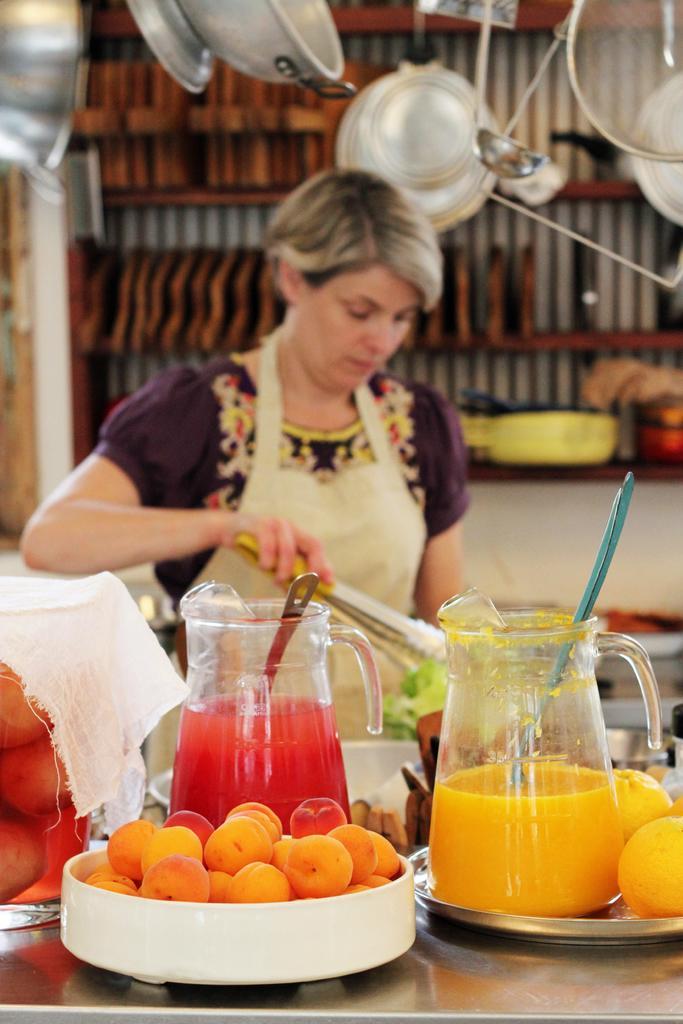Please provide a concise description of this image. In the middle of the picture, we see a woman is standing. She is holding something in her hands. In front of her, we see a table on which a bowl containing fruits, a plate containing oranges, two jars containing juices and spoons are placed on the table. On the left side, we see a glass containing liquid is covered with a white color cloth. In the background, we see a rack. At the top, we see many vessels. 